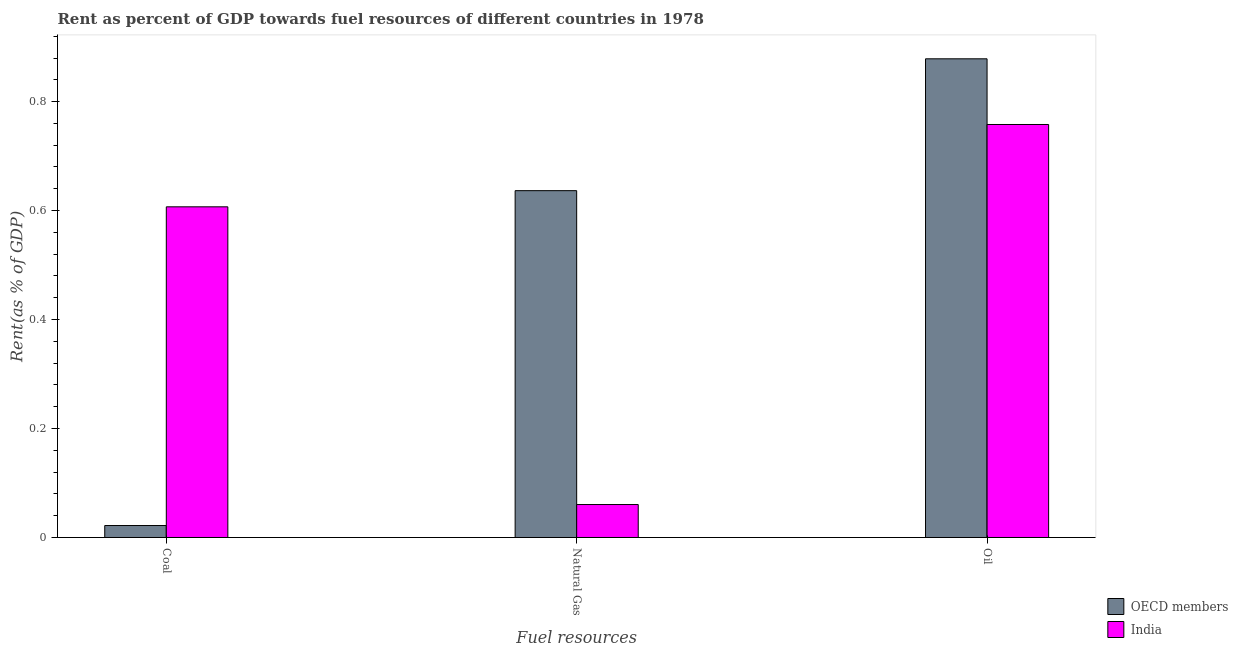How many groups of bars are there?
Provide a short and direct response. 3. Are the number of bars on each tick of the X-axis equal?
Your answer should be very brief. Yes. How many bars are there on the 3rd tick from the left?
Ensure brevity in your answer.  2. What is the label of the 3rd group of bars from the left?
Offer a very short reply. Oil. What is the rent towards coal in India?
Make the answer very short. 0.61. Across all countries, what is the maximum rent towards oil?
Your response must be concise. 0.88. Across all countries, what is the minimum rent towards coal?
Offer a very short reply. 0.02. In which country was the rent towards coal maximum?
Ensure brevity in your answer.  India. In which country was the rent towards oil minimum?
Give a very brief answer. India. What is the total rent towards natural gas in the graph?
Make the answer very short. 0.7. What is the difference between the rent towards coal in India and that in OECD members?
Make the answer very short. 0.58. What is the difference between the rent towards natural gas in OECD members and the rent towards oil in India?
Ensure brevity in your answer.  -0.12. What is the average rent towards coal per country?
Provide a short and direct response. 0.31. What is the difference between the rent towards coal and rent towards oil in OECD members?
Your answer should be very brief. -0.86. In how many countries, is the rent towards coal greater than 0.6400000000000001 %?
Provide a short and direct response. 0. What is the ratio of the rent towards coal in India to that in OECD members?
Make the answer very short. 27.65. Is the difference between the rent towards oil in OECD members and India greater than the difference between the rent towards coal in OECD members and India?
Your answer should be compact. Yes. What is the difference between the highest and the second highest rent towards natural gas?
Your answer should be compact. 0.58. What is the difference between the highest and the lowest rent towards coal?
Provide a succinct answer. 0.58. Is the sum of the rent towards coal in OECD members and India greater than the maximum rent towards natural gas across all countries?
Your answer should be compact. No. What does the 1st bar from the left in Oil represents?
Keep it short and to the point. OECD members. What does the 2nd bar from the right in Oil represents?
Make the answer very short. OECD members. Is it the case that in every country, the sum of the rent towards coal and rent towards natural gas is greater than the rent towards oil?
Provide a succinct answer. No. Are all the bars in the graph horizontal?
Provide a short and direct response. No. How many countries are there in the graph?
Offer a terse response. 2. Are the values on the major ticks of Y-axis written in scientific E-notation?
Give a very brief answer. No. What is the title of the graph?
Your answer should be compact. Rent as percent of GDP towards fuel resources of different countries in 1978. What is the label or title of the X-axis?
Ensure brevity in your answer.  Fuel resources. What is the label or title of the Y-axis?
Keep it short and to the point. Rent(as % of GDP). What is the Rent(as % of GDP) in OECD members in Coal?
Provide a succinct answer. 0.02. What is the Rent(as % of GDP) in India in Coal?
Your answer should be compact. 0.61. What is the Rent(as % of GDP) of OECD members in Natural Gas?
Your answer should be compact. 0.64. What is the Rent(as % of GDP) in India in Natural Gas?
Provide a short and direct response. 0.06. What is the Rent(as % of GDP) of OECD members in Oil?
Offer a terse response. 0.88. What is the Rent(as % of GDP) in India in Oil?
Make the answer very short. 0.76. Across all Fuel resources, what is the maximum Rent(as % of GDP) of OECD members?
Ensure brevity in your answer.  0.88. Across all Fuel resources, what is the maximum Rent(as % of GDP) in India?
Provide a short and direct response. 0.76. Across all Fuel resources, what is the minimum Rent(as % of GDP) of OECD members?
Offer a very short reply. 0.02. Across all Fuel resources, what is the minimum Rent(as % of GDP) in India?
Give a very brief answer. 0.06. What is the total Rent(as % of GDP) of OECD members in the graph?
Provide a short and direct response. 1.54. What is the total Rent(as % of GDP) of India in the graph?
Give a very brief answer. 1.43. What is the difference between the Rent(as % of GDP) of OECD members in Coal and that in Natural Gas?
Your response must be concise. -0.61. What is the difference between the Rent(as % of GDP) of India in Coal and that in Natural Gas?
Provide a succinct answer. 0.55. What is the difference between the Rent(as % of GDP) of OECD members in Coal and that in Oil?
Keep it short and to the point. -0.86. What is the difference between the Rent(as % of GDP) in India in Coal and that in Oil?
Your answer should be very brief. -0.15. What is the difference between the Rent(as % of GDP) in OECD members in Natural Gas and that in Oil?
Keep it short and to the point. -0.24. What is the difference between the Rent(as % of GDP) in India in Natural Gas and that in Oil?
Your answer should be compact. -0.7. What is the difference between the Rent(as % of GDP) in OECD members in Coal and the Rent(as % of GDP) in India in Natural Gas?
Offer a terse response. -0.04. What is the difference between the Rent(as % of GDP) in OECD members in Coal and the Rent(as % of GDP) in India in Oil?
Ensure brevity in your answer.  -0.74. What is the difference between the Rent(as % of GDP) of OECD members in Natural Gas and the Rent(as % of GDP) of India in Oil?
Your response must be concise. -0.12. What is the average Rent(as % of GDP) in OECD members per Fuel resources?
Provide a short and direct response. 0.51. What is the average Rent(as % of GDP) of India per Fuel resources?
Give a very brief answer. 0.48. What is the difference between the Rent(as % of GDP) in OECD members and Rent(as % of GDP) in India in Coal?
Your response must be concise. -0.58. What is the difference between the Rent(as % of GDP) in OECD members and Rent(as % of GDP) in India in Natural Gas?
Offer a terse response. 0.58. What is the difference between the Rent(as % of GDP) of OECD members and Rent(as % of GDP) of India in Oil?
Your response must be concise. 0.12. What is the ratio of the Rent(as % of GDP) in OECD members in Coal to that in Natural Gas?
Give a very brief answer. 0.03. What is the ratio of the Rent(as % of GDP) in India in Coal to that in Natural Gas?
Offer a terse response. 10.03. What is the ratio of the Rent(as % of GDP) of OECD members in Coal to that in Oil?
Your response must be concise. 0.03. What is the ratio of the Rent(as % of GDP) in India in Coal to that in Oil?
Give a very brief answer. 0.8. What is the ratio of the Rent(as % of GDP) of OECD members in Natural Gas to that in Oil?
Make the answer very short. 0.72. What is the ratio of the Rent(as % of GDP) of India in Natural Gas to that in Oil?
Offer a very short reply. 0.08. What is the difference between the highest and the second highest Rent(as % of GDP) in OECD members?
Offer a terse response. 0.24. What is the difference between the highest and the second highest Rent(as % of GDP) of India?
Give a very brief answer. 0.15. What is the difference between the highest and the lowest Rent(as % of GDP) of OECD members?
Offer a terse response. 0.86. What is the difference between the highest and the lowest Rent(as % of GDP) in India?
Give a very brief answer. 0.7. 